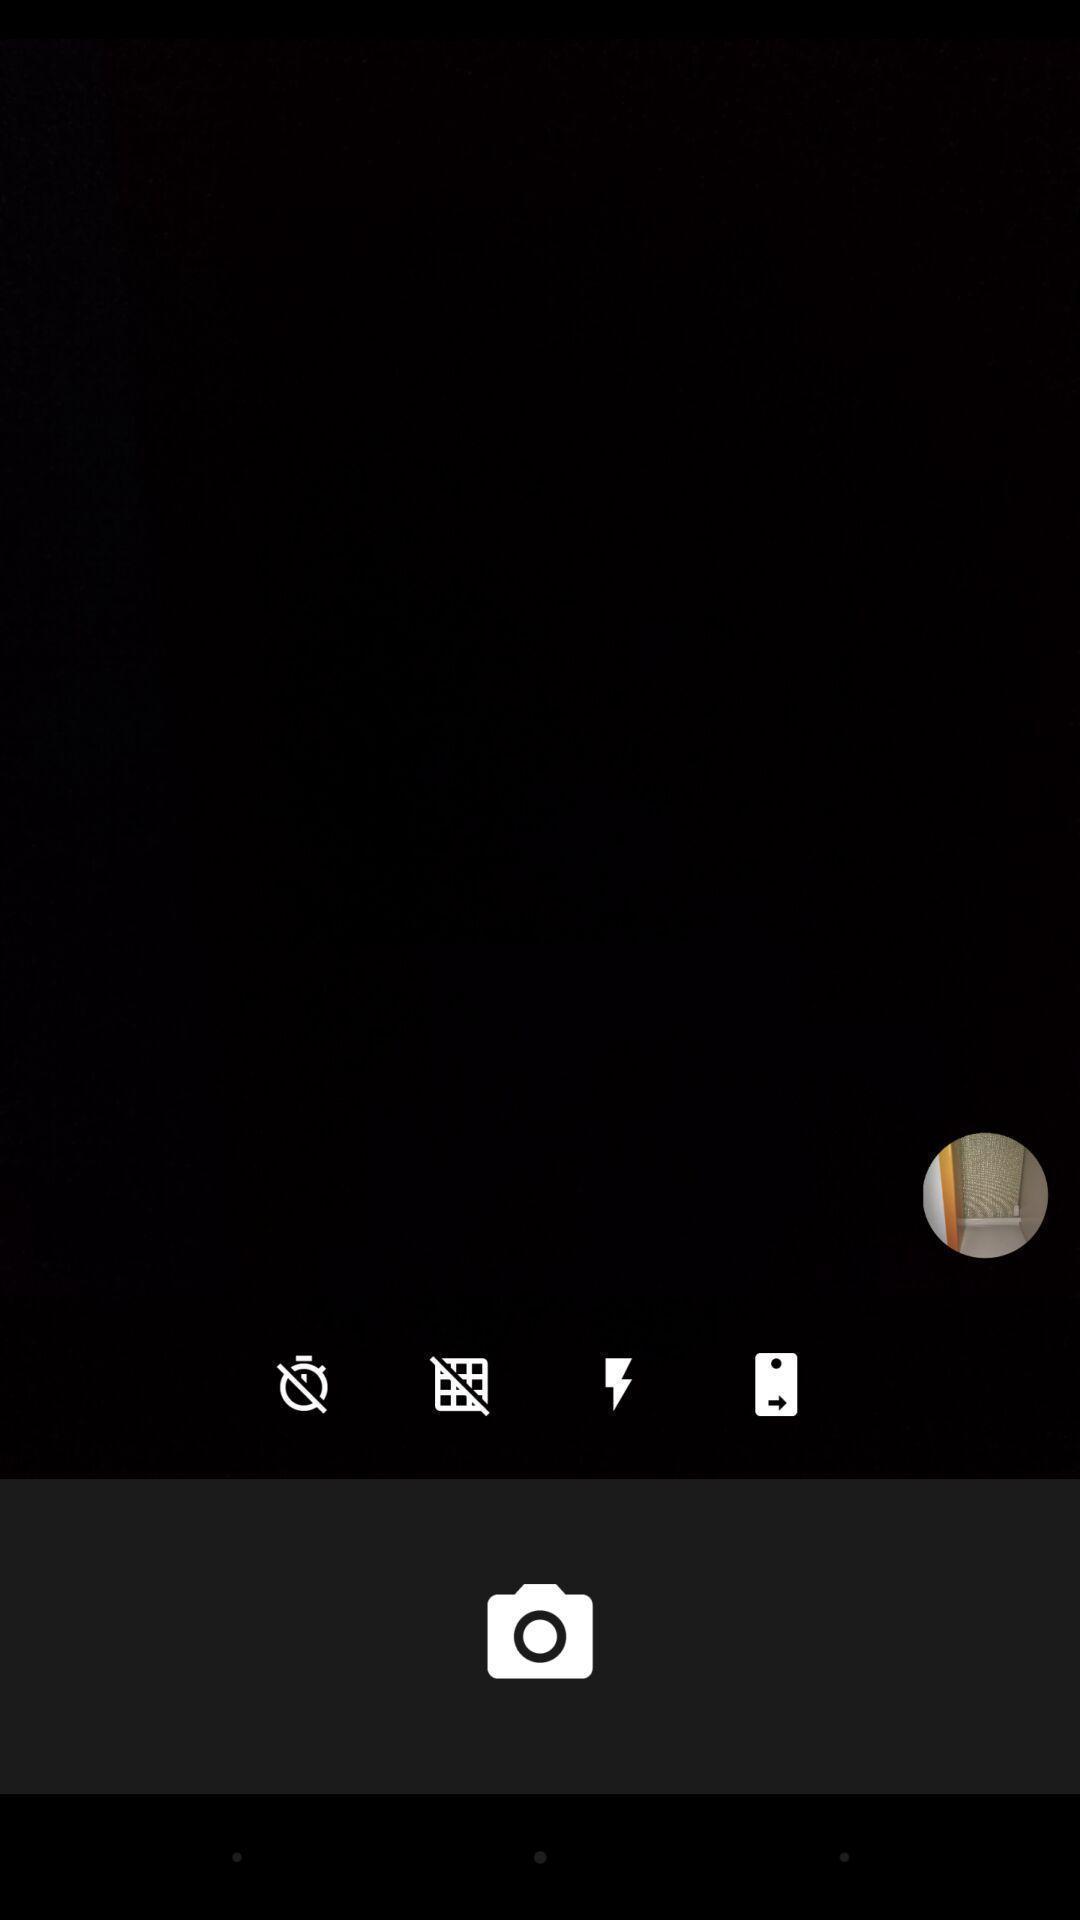Summarize the information in this screenshot. Page displaying about the camera application. 